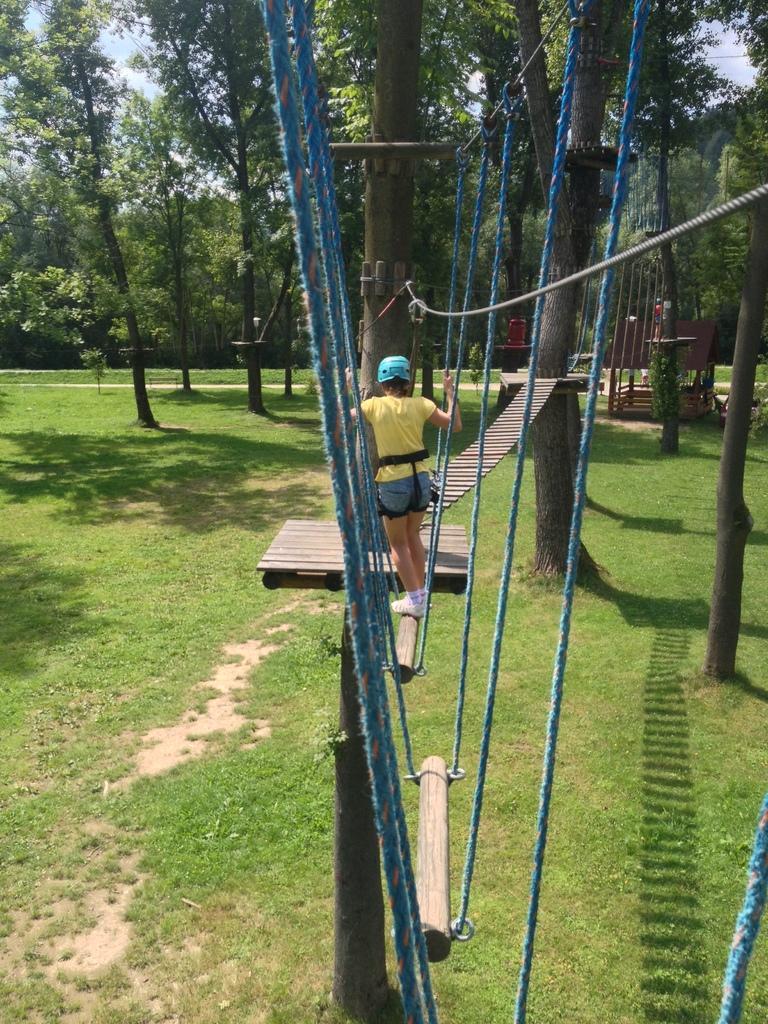In one or two sentences, can you explain what this image depicts? In this picture we can see a person wore helmet and standing on a wooden pole and in the background we can see a path, trees, grass, sky. 